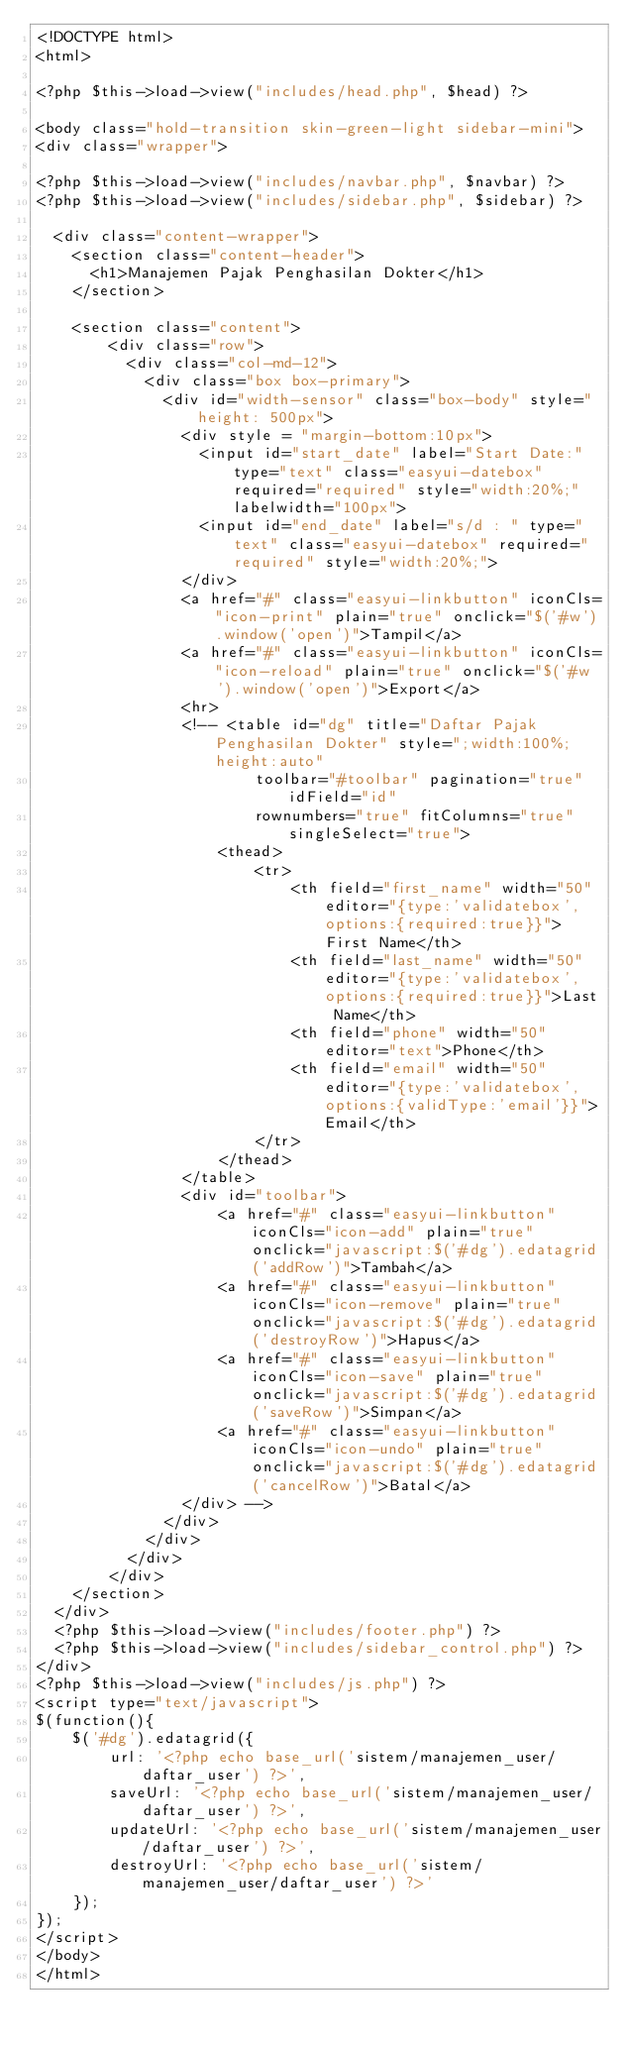Convert code to text. <code><loc_0><loc_0><loc_500><loc_500><_PHP_><!DOCTYPE html>
<html>

<?php $this->load->view("includes/head.php", $head) ?>

<body class="hold-transition skin-green-light sidebar-mini">
<div class="wrapper">

<?php $this->load->view("includes/navbar.php", $navbar) ?>
<?php $this->load->view("includes/sidebar.php", $sidebar) ?>

  <div class="content-wrapper">
    <section class="content-header">
      <h1>Manajemen Pajak Penghasilan Dokter</h1>
    </section>

    <section class="content">
        <div class="row">
          <div class="col-md-12">
            <div class="box box-primary">
              <div id="width-sensor" class="box-body" style="height: 500px">
                <div style = "margin-bottom:10px">
                  <input id="start_date" label="Start Date:" type="text" class="easyui-datebox" required="required" style="width:20%;" labelwidth="100px">
                  <input id="end_date" label="s/d : " type="text" class="easyui-datebox" required="required" style="width:20%;">
                </div>
                <a href="#" class="easyui-linkbutton" iconCls="icon-print" plain="true" onclick="$('#w').window('open')">Tampil</a>
                <a href="#" class="easyui-linkbutton" iconCls="icon-reload" plain="true" onclick="$('#w').window('open')">Export</a>
                <hr>
                <!-- <table id="dg" title="Daftar Pajak Penghasilan Dokter" style=";width:100%;height:auto"
                		toolbar="#toolbar" pagination="true" idField="id"
                		rownumbers="true" fitColumns="true" singleSelect="true">
                	<thead>
                		<tr>
                			<th field="first_name" width="50" editor="{type:'validatebox',options:{required:true}}">First Name</th>
                			<th field="last_name" width="50" editor="{type:'validatebox',options:{required:true}}">Last Name</th>
                			<th field="phone" width="50" editor="text">Phone</th>
                			<th field="email" width="50" editor="{type:'validatebox',options:{validType:'email'}}">Email</th>
                		</tr>
                	</thead>
                </table>
                <div id="toolbar">
                	<a href="#" class="easyui-linkbutton" iconCls="icon-add" plain="true" onclick="javascript:$('#dg').edatagrid('addRow')">Tambah</a>
                	<a href="#" class="easyui-linkbutton" iconCls="icon-remove" plain="true" onclick="javascript:$('#dg').edatagrid('destroyRow')">Hapus</a>
                	<a href="#" class="easyui-linkbutton" iconCls="icon-save" plain="true" onclick="javascript:$('#dg').edatagrid('saveRow')">Simpan</a>
                	<a href="#" class="easyui-linkbutton" iconCls="icon-undo" plain="true" onclick="javascript:$('#dg').edatagrid('cancelRow')">Batal</a>
                </div> -->
              </div>
            </div>
          </div>
        </div>
    </section>
  </div>
  <?php $this->load->view("includes/footer.php") ?>
  <?php $this->load->view("includes/sidebar_control.php") ?>
</div>
<?php $this->load->view("includes/js.php") ?>
<script type="text/javascript">
$(function(){
    $('#dg').edatagrid({
        url: '<?php echo base_url('sistem/manajemen_user/daftar_user') ?>',
        saveUrl: '<?php echo base_url('sistem/manajemen_user/daftar_user') ?>',
        updateUrl: '<?php echo base_url('sistem/manajemen_user/daftar_user') ?>',
        destroyUrl: '<?php echo base_url('sistem/manajemen_user/daftar_user') ?>'
    });
});
</script>
</body>
</html>
</code> 